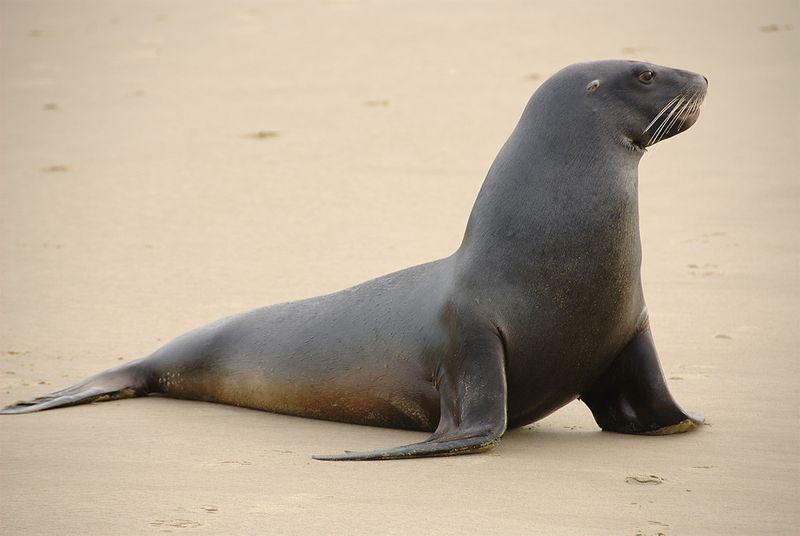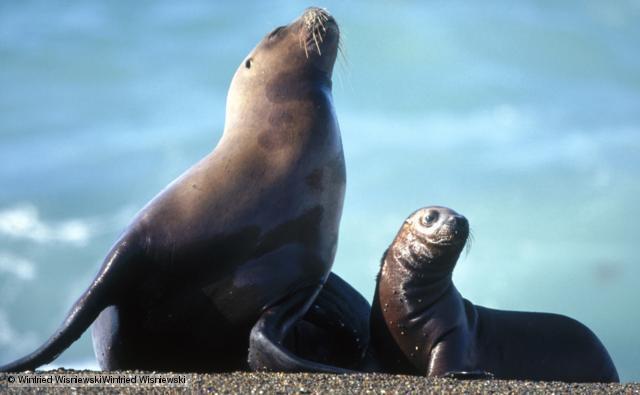The first image is the image on the left, the second image is the image on the right. For the images shown, is this caption "The right image shows just one young seal looking forward." true? Answer yes or no. No. 